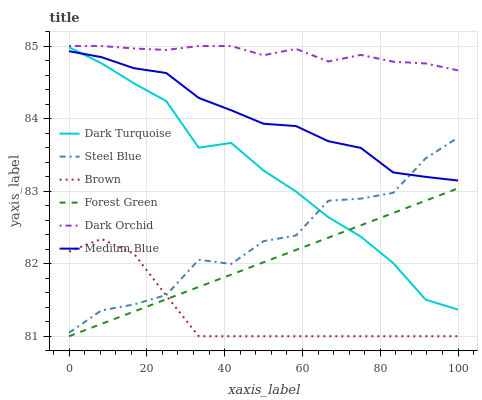Does Brown have the minimum area under the curve?
Answer yes or no. Yes. Does Dark Orchid have the maximum area under the curve?
Answer yes or no. Yes. Does Dark Turquoise have the minimum area under the curve?
Answer yes or no. No. Does Dark Turquoise have the maximum area under the curve?
Answer yes or no. No. Is Forest Green the smoothest?
Answer yes or no. Yes. Is Steel Blue the roughest?
Answer yes or no. Yes. Is Dark Turquoise the smoothest?
Answer yes or no. No. Is Dark Turquoise the roughest?
Answer yes or no. No. Does Brown have the lowest value?
Answer yes or no. Yes. Does Dark Turquoise have the lowest value?
Answer yes or no. No. Does Dark Orchid have the highest value?
Answer yes or no. Yes. Does Dark Turquoise have the highest value?
Answer yes or no. No. Is Forest Green less than Dark Orchid?
Answer yes or no. Yes. Is Steel Blue greater than Forest Green?
Answer yes or no. Yes. Does Forest Green intersect Dark Turquoise?
Answer yes or no. Yes. Is Forest Green less than Dark Turquoise?
Answer yes or no. No. Is Forest Green greater than Dark Turquoise?
Answer yes or no. No. Does Forest Green intersect Dark Orchid?
Answer yes or no. No. 